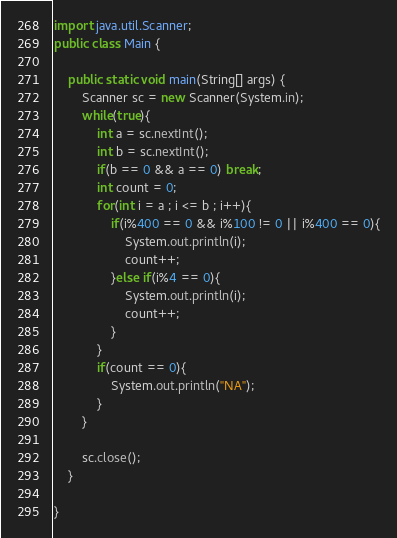Convert code to text. <code><loc_0><loc_0><loc_500><loc_500><_Java_>import java.util.Scanner;
public class Main {

	public static void main(String[] args) {
		Scanner sc = new Scanner(System.in);
		while(true){
			int a = sc.nextInt();
			int b = sc.nextInt();
			if(b == 0 && a == 0) break;
			int count = 0;
			for(int i = a ; i <= b ; i++){
				if(i%400 == 0 && i%100 != 0 || i%400 == 0){
					System.out.println(i);
					count++;
				}else if(i%4 == 0){
					System.out.println(i);
					count++;					
				}
			}
			if(count == 0){
				System.out.println("NA");
			}
		}
		
		sc.close();
	}

}</code> 